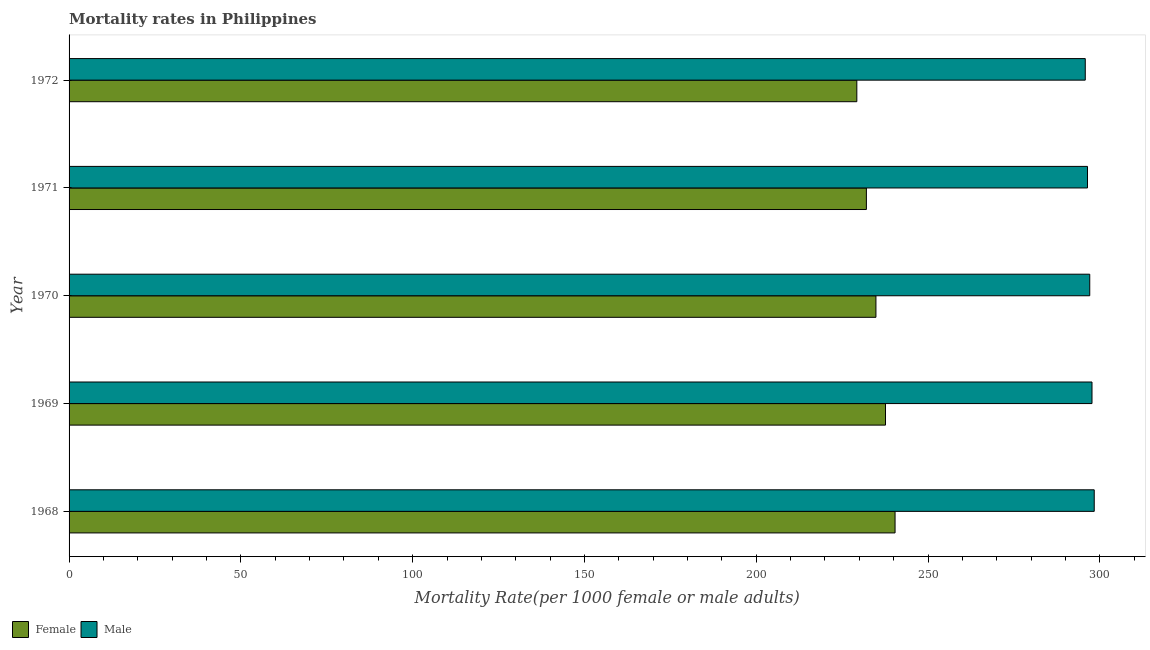How many different coloured bars are there?
Offer a very short reply. 2. How many groups of bars are there?
Provide a succinct answer. 5. Are the number of bars per tick equal to the number of legend labels?
Give a very brief answer. Yes. Are the number of bars on each tick of the Y-axis equal?
Keep it short and to the point. Yes. How many bars are there on the 5th tick from the top?
Provide a short and direct response. 2. What is the male mortality rate in 1968?
Offer a terse response. 298.36. Across all years, what is the maximum male mortality rate?
Your answer should be very brief. 298.36. Across all years, what is the minimum female mortality rate?
Keep it short and to the point. 229.27. In which year was the male mortality rate maximum?
Your response must be concise. 1968. What is the total male mortality rate in the graph?
Keep it short and to the point. 1485.3. What is the difference between the male mortality rate in 1968 and that in 1970?
Ensure brevity in your answer.  1.3. What is the difference between the female mortality rate in 1972 and the male mortality rate in 1969?
Provide a succinct answer. -68.44. What is the average female mortality rate per year?
Your response must be concise. 234.83. In the year 1969, what is the difference between the male mortality rate and female mortality rate?
Ensure brevity in your answer.  60.1. What is the ratio of the female mortality rate in 1968 to that in 1970?
Offer a very short reply. 1.02. Is the female mortality rate in 1970 less than that in 1972?
Your answer should be compact. No. What is the difference between the highest and the second highest male mortality rate?
Give a very brief answer. 0.65. What is the difference between the highest and the lowest male mortality rate?
Offer a very short reply. 2.61. What does the 1st bar from the top in 1969 represents?
Offer a very short reply. Male. What does the 2nd bar from the bottom in 1970 represents?
Give a very brief answer. Male. Are all the bars in the graph horizontal?
Your response must be concise. Yes. What is the difference between two consecutive major ticks on the X-axis?
Give a very brief answer. 50. How are the legend labels stacked?
Your answer should be very brief. Horizontal. What is the title of the graph?
Provide a short and direct response. Mortality rates in Philippines. Does "Age 65(female)" appear as one of the legend labels in the graph?
Make the answer very short. No. What is the label or title of the X-axis?
Provide a succinct answer. Mortality Rate(per 1000 female or male adults). What is the label or title of the Y-axis?
Give a very brief answer. Year. What is the Mortality Rate(per 1000 female or male adults) of Female in 1968?
Offer a terse response. 240.4. What is the Mortality Rate(per 1000 female or male adults) in Male in 1968?
Make the answer very short. 298.36. What is the Mortality Rate(per 1000 female or male adults) of Female in 1969?
Your answer should be very brief. 237.62. What is the Mortality Rate(per 1000 female or male adults) of Male in 1969?
Keep it short and to the point. 297.71. What is the Mortality Rate(per 1000 female or male adults) in Female in 1970?
Provide a short and direct response. 234.83. What is the Mortality Rate(per 1000 female or male adults) of Male in 1970?
Ensure brevity in your answer.  297.06. What is the Mortality Rate(per 1000 female or male adults) of Female in 1971?
Provide a short and direct response. 232.05. What is the Mortality Rate(per 1000 female or male adults) in Male in 1971?
Offer a very short reply. 296.41. What is the Mortality Rate(per 1000 female or male adults) of Female in 1972?
Your answer should be very brief. 229.27. What is the Mortality Rate(per 1000 female or male adults) of Male in 1972?
Give a very brief answer. 295.75. Across all years, what is the maximum Mortality Rate(per 1000 female or male adults) in Female?
Ensure brevity in your answer.  240.4. Across all years, what is the maximum Mortality Rate(per 1000 female or male adults) of Male?
Your answer should be very brief. 298.36. Across all years, what is the minimum Mortality Rate(per 1000 female or male adults) of Female?
Your answer should be very brief. 229.27. Across all years, what is the minimum Mortality Rate(per 1000 female or male adults) in Male?
Provide a succinct answer. 295.75. What is the total Mortality Rate(per 1000 female or male adults) of Female in the graph?
Provide a short and direct response. 1174.16. What is the total Mortality Rate(per 1000 female or male adults) of Male in the graph?
Give a very brief answer. 1485.3. What is the difference between the Mortality Rate(per 1000 female or male adults) of Female in 1968 and that in 1969?
Your answer should be very brief. 2.78. What is the difference between the Mortality Rate(per 1000 female or male adults) of Male in 1968 and that in 1969?
Offer a terse response. 0.65. What is the difference between the Mortality Rate(per 1000 female or male adults) in Female in 1968 and that in 1970?
Provide a short and direct response. 5.56. What is the difference between the Mortality Rate(per 1000 female or male adults) in Male in 1968 and that in 1970?
Offer a terse response. 1.3. What is the difference between the Mortality Rate(per 1000 female or male adults) in Female in 1968 and that in 1971?
Offer a very short reply. 8.35. What is the difference between the Mortality Rate(per 1000 female or male adults) of Male in 1968 and that in 1971?
Keep it short and to the point. 1.96. What is the difference between the Mortality Rate(per 1000 female or male adults) of Female in 1968 and that in 1972?
Give a very brief answer. 11.13. What is the difference between the Mortality Rate(per 1000 female or male adults) in Male in 1968 and that in 1972?
Provide a succinct answer. 2.61. What is the difference between the Mortality Rate(per 1000 female or male adults) of Female in 1969 and that in 1970?
Provide a succinct answer. 2.78. What is the difference between the Mortality Rate(per 1000 female or male adults) of Male in 1969 and that in 1970?
Your answer should be very brief. 0.65. What is the difference between the Mortality Rate(per 1000 female or male adults) of Female in 1969 and that in 1971?
Offer a terse response. 5.56. What is the difference between the Mortality Rate(per 1000 female or male adults) of Male in 1969 and that in 1971?
Make the answer very short. 1.31. What is the difference between the Mortality Rate(per 1000 female or male adults) in Female in 1969 and that in 1972?
Your response must be concise. 8.35. What is the difference between the Mortality Rate(per 1000 female or male adults) of Male in 1969 and that in 1972?
Ensure brevity in your answer.  1.96. What is the difference between the Mortality Rate(per 1000 female or male adults) in Female in 1970 and that in 1971?
Your answer should be compact. 2.78. What is the difference between the Mortality Rate(per 1000 female or male adults) in Male in 1970 and that in 1971?
Your answer should be compact. 0.65. What is the difference between the Mortality Rate(per 1000 female or male adults) in Female in 1970 and that in 1972?
Keep it short and to the point. 5.56. What is the difference between the Mortality Rate(per 1000 female or male adults) in Male in 1970 and that in 1972?
Make the answer very short. 1.3. What is the difference between the Mortality Rate(per 1000 female or male adults) of Female in 1971 and that in 1972?
Provide a short and direct response. 2.78. What is the difference between the Mortality Rate(per 1000 female or male adults) in Male in 1971 and that in 1972?
Provide a short and direct response. 0.65. What is the difference between the Mortality Rate(per 1000 female or male adults) of Female in 1968 and the Mortality Rate(per 1000 female or male adults) of Male in 1969?
Offer a terse response. -57.31. What is the difference between the Mortality Rate(per 1000 female or male adults) in Female in 1968 and the Mortality Rate(per 1000 female or male adults) in Male in 1970?
Offer a terse response. -56.66. What is the difference between the Mortality Rate(per 1000 female or male adults) of Female in 1968 and the Mortality Rate(per 1000 female or male adults) of Male in 1971?
Provide a short and direct response. -56.01. What is the difference between the Mortality Rate(per 1000 female or male adults) of Female in 1968 and the Mortality Rate(per 1000 female or male adults) of Male in 1972?
Provide a succinct answer. -55.36. What is the difference between the Mortality Rate(per 1000 female or male adults) of Female in 1969 and the Mortality Rate(per 1000 female or male adults) of Male in 1970?
Give a very brief answer. -59.44. What is the difference between the Mortality Rate(per 1000 female or male adults) in Female in 1969 and the Mortality Rate(per 1000 female or male adults) in Male in 1971?
Provide a succinct answer. -58.79. What is the difference between the Mortality Rate(per 1000 female or male adults) in Female in 1969 and the Mortality Rate(per 1000 female or male adults) in Male in 1972?
Ensure brevity in your answer.  -58.14. What is the difference between the Mortality Rate(per 1000 female or male adults) of Female in 1970 and the Mortality Rate(per 1000 female or male adults) of Male in 1971?
Your answer should be compact. -61.57. What is the difference between the Mortality Rate(per 1000 female or male adults) in Female in 1970 and the Mortality Rate(per 1000 female or male adults) in Male in 1972?
Your answer should be compact. -60.92. What is the difference between the Mortality Rate(per 1000 female or male adults) of Female in 1971 and the Mortality Rate(per 1000 female or male adults) of Male in 1972?
Provide a succinct answer. -63.7. What is the average Mortality Rate(per 1000 female or male adults) in Female per year?
Provide a succinct answer. 234.83. What is the average Mortality Rate(per 1000 female or male adults) in Male per year?
Give a very brief answer. 297.06. In the year 1968, what is the difference between the Mortality Rate(per 1000 female or male adults) in Female and Mortality Rate(per 1000 female or male adults) in Male?
Your response must be concise. -57.97. In the year 1969, what is the difference between the Mortality Rate(per 1000 female or male adults) of Female and Mortality Rate(per 1000 female or male adults) of Male?
Make the answer very short. -60.1. In the year 1970, what is the difference between the Mortality Rate(per 1000 female or male adults) in Female and Mortality Rate(per 1000 female or male adults) in Male?
Give a very brief answer. -62.23. In the year 1971, what is the difference between the Mortality Rate(per 1000 female or male adults) in Female and Mortality Rate(per 1000 female or male adults) in Male?
Provide a short and direct response. -64.36. In the year 1972, what is the difference between the Mortality Rate(per 1000 female or male adults) of Female and Mortality Rate(per 1000 female or male adults) of Male?
Your answer should be very brief. -66.48. What is the ratio of the Mortality Rate(per 1000 female or male adults) of Female in 1968 to that in 1969?
Your answer should be very brief. 1.01. What is the ratio of the Mortality Rate(per 1000 female or male adults) in Male in 1968 to that in 1969?
Your answer should be compact. 1. What is the ratio of the Mortality Rate(per 1000 female or male adults) in Female in 1968 to that in 1970?
Your answer should be compact. 1.02. What is the ratio of the Mortality Rate(per 1000 female or male adults) of Male in 1968 to that in 1970?
Offer a terse response. 1. What is the ratio of the Mortality Rate(per 1000 female or male adults) in Female in 1968 to that in 1971?
Offer a terse response. 1.04. What is the ratio of the Mortality Rate(per 1000 female or male adults) of Male in 1968 to that in 1971?
Your answer should be compact. 1.01. What is the ratio of the Mortality Rate(per 1000 female or male adults) of Female in 1968 to that in 1972?
Your answer should be compact. 1.05. What is the ratio of the Mortality Rate(per 1000 female or male adults) of Male in 1968 to that in 1972?
Ensure brevity in your answer.  1.01. What is the ratio of the Mortality Rate(per 1000 female or male adults) of Female in 1969 to that in 1970?
Offer a very short reply. 1.01. What is the ratio of the Mortality Rate(per 1000 female or male adults) in Male in 1969 to that in 1970?
Provide a succinct answer. 1. What is the ratio of the Mortality Rate(per 1000 female or male adults) in Female in 1969 to that in 1971?
Give a very brief answer. 1.02. What is the ratio of the Mortality Rate(per 1000 female or male adults) in Female in 1969 to that in 1972?
Provide a succinct answer. 1.04. What is the ratio of the Mortality Rate(per 1000 female or male adults) of Male in 1969 to that in 1972?
Provide a succinct answer. 1.01. What is the ratio of the Mortality Rate(per 1000 female or male adults) of Male in 1970 to that in 1971?
Provide a short and direct response. 1. What is the ratio of the Mortality Rate(per 1000 female or male adults) in Female in 1970 to that in 1972?
Give a very brief answer. 1.02. What is the ratio of the Mortality Rate(per 1000 female or male adults) in Male in 1970 to that in 1972?
Give a very brief answer. 1. What is the ratio of the Mortality Rate(per 1000 female or male adults) of Female in 1971 to that in 1972?
Offer a terse response. 1.01. What is the ratio of the Mortality Rate(per 1000 female or male adults) of Male in 1971 to that in 1972?
Your response must be concise. 1. What is the difference between the highest and the second highest Mortality Rate(per 1000 female or male adults) of Female?
Ensure brevity in your answer.  2.78. What is the difference between the highest and the second highest Mortality Rate(per 1000 female or male adults) in Male?
Your answer should be compact. 0.65. What is the difference between the highest and the lowest Mortality Rate(per 1000 female or male adults) of Female?
Your answer should be compact. 11.13. What is the difference between the highest and the lowest Mortality Rate(per 1000 female or male adults) of Male?
Give a very brief answer. 2.61. 